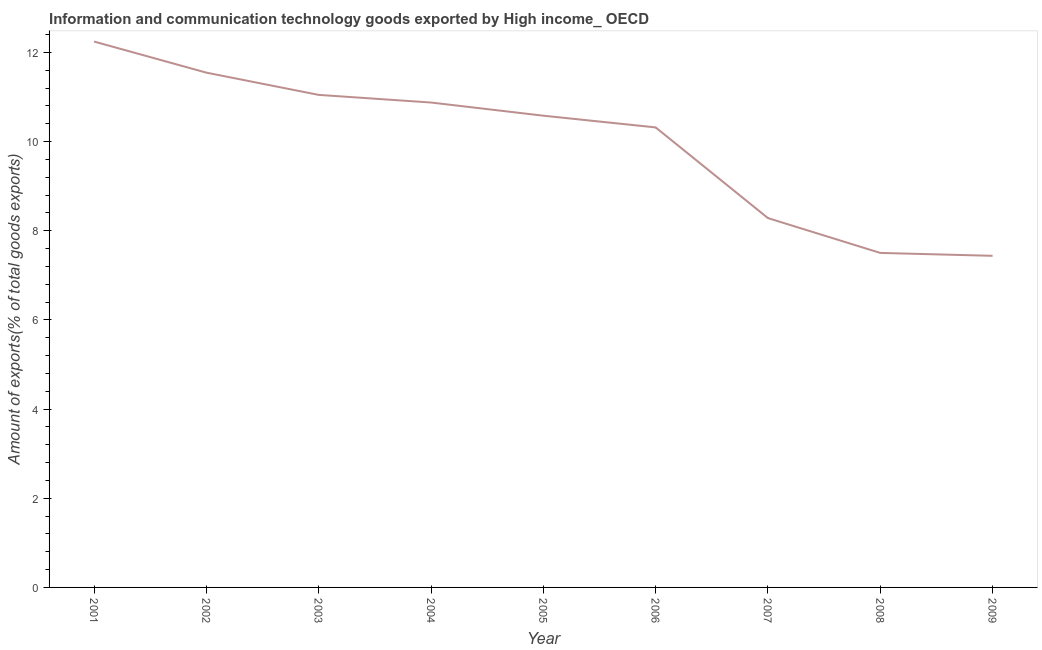What is the amount of ict goods exports in 2002?
Your response must be concise. 11.55. Across all years, what is the maximum amount of ict goods exports?
Keep it short and to the point. 12.24. Across all years, what is the minimum amount of ict goods exports?
Keep it short and to the point. 7.44. What is the sum of the amount of ict goods exports?
Give a very brief answer. 89.83. What is the difference between the amount of ict goods exports in 2004 and 2005?
Offer a very short reply. 0.3. What is the average amount of ict goods exports per year?
Ensure brevity in your answer.  9.98. What is the median amount of ict goods exports?
Offer a terse response. 10.58. Do a majority of the years between 2004 and 2007 (inclusive) have amount of ict goods exports greater than 1.2000000000000002 %?
Make the answer very short. Yes. What is the ratio of the amount of ict goods exports in 2006 to that in 2007?
Your answer should be compact. 1.25. Is the difference between the amount of ict goods exports in 2002 and 2006 greater than the difference between any two years?
Provide a short and direct response. No. What is the difference between the highest and the second highest amount of ict goods exports?
Your answer should be compact. 0.7. What is the difference between the highest and the lowest amount of ict goods exports?
Ensure brevity in your answer.  4.81. Does the amount of ict goods exports monotonically increase over the years?
Your answer should be very brief. No. How many years are there in the graph?
Your response must be concise. 9. Are the values on the major ticks of Y-axis written in scientific E-notation?
Make the answer very short. No. Does the graph contain any zero values?
Make the answer very short. No. What is the title of the graph?
Ensure brevity in your answer.  Information and communication technology goods exported by High income_ OECD. What is the label or title of the Y-axis?
Ensure brevity in your answer.  Amount of exports(% of total goods exports). What is the Amount of exports(% of total goods exports) in 2001?
Keep it short and to the point. 12.24. What is the Amount of exports(% of total goods exports) in 2002?
Your answer should be very brief. 11.55. What is the Amount of exports(% of total goods exports) in 2003?
Your response must be concise. 11.05. What is the Amount of exports(% of total goods exports) of 2004?
Ensure brevity in your answer.  10.88. What is the Amount of exports(% of total goods exports) of 2005?
Provide a succinct answer. 10.58. What is the Amount of exports(% of total goods exports) of 2006?
Your answer should be very brief. 10.32. What is the Amount of exports(% of total goods exports) of 2007?
Provide a succinct answer. 8.28. What is the Amount of exports(% of total goods exports) of 2008?
Ensure brevity in your answer.  7.5. What is the Amount of exports(% of total goods exports) in 2009?
Your answer should be very brief. 7.44. What is the difference between the Amount of exports(% of total goods exports) in 2001 and 2002?
Your answer should be compact. 0.7. What is the difference between the Amount of exports(% of total goods exports) in 2001 and 2003?
Offer a terse response. 1.2. What is the difference between the Amount of exports(% of total goods exports) in 2001 and 2004?
Keep it short and to the point. 1.37. What is the difference between the Amount of exports(% of total goods exports) in 2001 and 2005?
Provide a short and direct response. 1.66. What is the difference between the Amount of exports(% of total goods exports) in 2001 and 2006?
Your response must be concise. 1.93. What is the difference between the Amount of exports(% of total goods exports) in 2001 and 2007?
Provide a succinct answer. 3.96. What is the difference between the Amount of exports(% of total goods exports) in 2001 and 2008?
Offer a very short reply. 4.74. What is the difference between the Amount of exports(% of total goods exports) in 2001 and 2009?
Your answer should be very brief. 4.81. What is the difference between the Amount of exports(% of total goods exports) in 2002 and 2003?
Keep it short and to the point. 0.5. What is the difference between the Amount of exports(% of total goods exports) in 2002 and 2004?
Offer a very short reply. 0.67. What is the difference between the Amount of exports(% of total goods exports) in 2002 and 2005?
Ensure brevity in your answer.  0.97. What is the difference between the Amount of exports(% of total goods exports) in 2002 and 2006?
Offer a terse response. 1.23. What is the difference between the Amount of exports(% of total goods exports) in 2002 and 2007?
Your answer should be very brief. 3.26. What is the difference between the Amount of exports(% of total goods exports) in 2002 and 2008?
Offer a terse response. 4.04. What is the difference between the Amount of exports(% of total goods exports) in 2002 and 2009?
Keep it short and to the point. 4.11. What is the difference between the Amount of exports(% of total goods exports) in 2003 and 2004?
Offer a terse response. 0.17. What is the difference between the Amount of exports(% of total goods exports) in 2003 and 2005?
Your answer should be very brief. 0.47. What is the difference between the Amount of exports(% of total goods exports) in 2003 and 2006?
Ensure brevity in your answer.  0.73. What is the difference between the Amount of exports(% of total goods exports) in 2003 and 2007?
Keep it short and to the point. 2.76. What is the difference between the Amount of exports(% of total goods exports) in 2003 and 2008?
Provide a short and direct response. 3.54. What is the difference between the Amount of exports(% of total goods exports) in 2003 and 2009?
Your response must be concise. 3.61. What is the difference between the Amount of exports(% of total goods exports) in 2004 and 2005?
Ensure brevity in your answer.  0.3. What is the difference between the Amount of exports(% of total goods exports) in 2004 and 2006?
Provide a succinct answer. 0.56. What is the difference between the Amount of exports(% of total goods exports) in 2004 and 2007?
Ensure brevity in your answer.  2.59. What is the difference between the Amount of exports(% of total goods exports) in 2004 and 2008?
Your answer should be compact. 3.37. What is the difference between the Amount of exports(% of total goods exports) in 2004 and 2009?
Keep it short and to the point. 3.44. What is the difference between the Amount of exports(% of total goods exports) in 2005 and 2006?
Your response must be concise. 0.26. What is the difference between the Amount of exports(% of total goods exports) in 2005 and 2007?
Your answer should be very brief. 2.3. What is the difference between the Amount of exports(% of total goods exports) in 2005 and 2008?
Ensure brevity in your answer.  3.08. What is the difference between the Amount of exports(% of total goods exports) in 2005 and 2009?
Make the answer very short. 3.14. What is the difference between the Amount of exports(% of total goods exports) in 2006 and 2007?
Provide a short and direct response. 2.03. What is the difference between the Amount of exports(% of total goods exports) in 2006 and 2008?
Offer a very short reply. 2.82. What is the difference between the Amount of exports(% of total goods exports) in 2006 and 2009?
Provide a succinct answer. 2.88. What is the difference between the Amount of exports(% of total goods exports) in 2007 and 2008?
Provide a succinct answer. 0.78. What is the difference between the Amount of exports(% of total goods exports) in 2007 and 2009?
Your answer should be very brief. 0.85. What is the difference between the Amount of exports(% of total goods exports) in 2008 and 2009?
Provide a short and direct response. 0.06. What is the ratio of the Amount of exports(% of total goods exports) in 2001 to that in 2002?
Offer a very short reply. 1.06. What is the ratio of the Amount of exports(% of total goods exports) in 2001 to that in 2003?
Provide a succinct answer. 1.11. What is the ratio of the Amount of exports(% of total goods exports) in 2001 to that in 2004?
Keep it short and to the point. 1.13. What is the ratio of the Amount of exports(% of total goods exports) in 2001 to that in 2005?
Provide a succinct answer. 1.16. What is the ratio of the Amount of exports(% of total goods exports) in 2001 to that in 2006?
Give a very brief answer. 1.19. What is the ratio of the Amount of exports(% of total goods exports) in 2001 to that in 2007?
Keep it short and to the point. 1.48. What is the ratio of the Amount of exports(% of total goods exports) in 2001 to that in 2008?
Keep it short and to the point. 1.63. What is the ratio of the Amount of exports(% of total goods exports) in 2001 to that in 2009?
Make the answer very short. 1.65. What is the ratio of the Amount of exports(% of total goods exports) in 2002 to that in 2003?
Your answer should be very brief. 1.04. What is the ratio of the Amount of exports(% of total goods exports) in 2002 to that in 2004?
Offer a terse response. 1.06. What is the ratio of the Amount of exports(% of total goods exports) in 2002 to that in 2005?
Ensure brevity in your answer.  1.09. What is the ratio of the Amount of exports(% of total goods exports) in 2002 to that in 2006?
Keep it short and to the point. 1.12. What is the ratio of the Amount of exports(% of total goods exports) in 2002 to that in 2007?
Offer a terse response. 1.39. What is the ratio of the Amount of exports(% of total goods exports) in 2002 to that in 2008?
Provide a succinct answer. 1.54. What is the ratio of the Amount of exports(% of total goods exports) in 2002 to that in 2009?
Keep it short and to the point. 1.55. What is the ratio of the Amount of exports(% of total goods exports) in 2003 to that in 2004?
Provide a succinct answer. 1.02. What is the ratio of the Amount of exports(% of total goods exports) in 2003 to that in 2005?
Make the answer very short. 1.04. What is the ratio of the Amount of exports(% of total goods exports) in 2003 to that in 2006?
Your response must be concise. 1.07. What is the ratio of the Amount of exports(% of total goods exports) in 2003 to that in 2007?
Keep it short and to the point. 1.33. What is the ratio of the Amount of exports(% of total goods exports) in 2003 to that in 2008?
Give a very brief answer. 1.47. What is the ratio of the Amount of exports(% of total goods exports) in 2003 to that in 2009?
Your answer should be compact. 1.49. What is the ratio of the Amount of exports(% of total goods exports) in 2004 to that in 2005?
Offer a terse response. 1.03. What is the ratio of the Amount of exports(% of total goods exports) in 2004 to that in 2006?
Offer a terse response. 1.05. What is the ratio of the Amount of exports(% of total goods exports) in 2004 to that in 2007?
Provide a short and direct response. 1.31. What is the ratio of the Amount of exports(% of total goods exports) in 2004 to that in 2008?
Offer a terse response. 1.45. What is the ratio of the Amount of exports(% of total goods exports) in 2004 to that in 2009?
Keep it short and to the point. 1.46. What is the ratio of the Amount of exports(% of total goods exports) in 2005 to that in 2006?
Give a very brief answer. 1.02. What is the ratio of the Amount of exports(% of total goods exports) in 2005 to that in 2007?
Ensure brevity in your answer.  1.28. What is the ratio of the Amount of exports(% of total goods exports) in 2005 to that in 2008?
Offer a very short reply. 1.41. What is the ratio of the Amount of exports(% of total goods exports) in 2005 to that in 2009?
Your answer should be very brief. 1.42. What is the ratio of the Amount of exports(% of total goods exports) in 2006 to that in 2007?
Your answer should be compact. 1.25. What is the ratio of the Amount of exports(% of total goods exports) in 2006 to that in 2008?
Your answer should be compact. 1.38. What is the ratio of the Amount of exports(% of total goods exports) in 2006 to that in 2009?
Provide a succinct answer. 1.39. What is the ratio of the Amount of exports(% of total goods exports) in 2007 to that in 2008?
Make the answer very short. 1.1. What is the ratio of the Amount of exports(% of total goods exports) in 2007 to that in 2009?
Provide a succinct answer. 1.11. What is the ratio of the Amount of exports(% of total goods exports) in 2008 to that in 2009?
Your answer should be very brief. 1.01. 